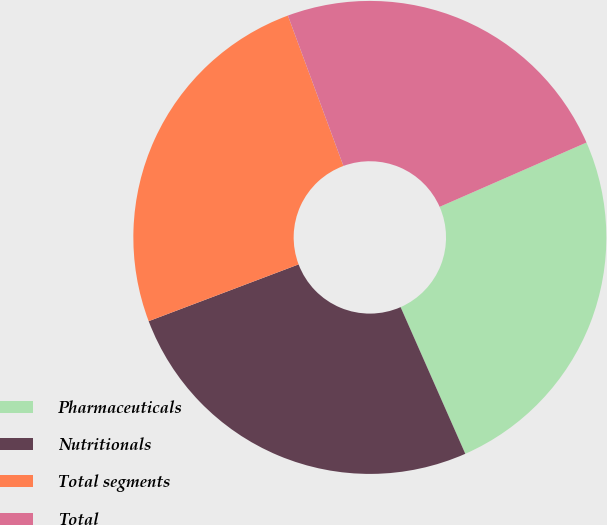<chart> <loc_0><loc_0><loc_500><loc_500><pie_chart><fcel>Pharmaceuticals<fcel>Nutritionals<fcel>Total segments<fcel>Total<nl><fcel>24.96%<fcel>25.85%<fcel>25.13%<fcel>24.06%<nl></chart> 